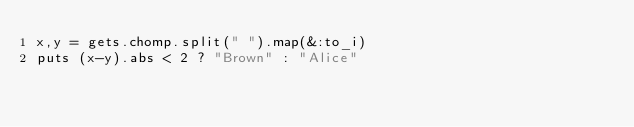<code> <loc_0><loc_0><loc_500><loc_500><_Ruby_>x,y = gets.chomp.split(" ").map(&:to_i)
puts (x-y).abs < 2 ? "Brown" : "Alice"</code> 